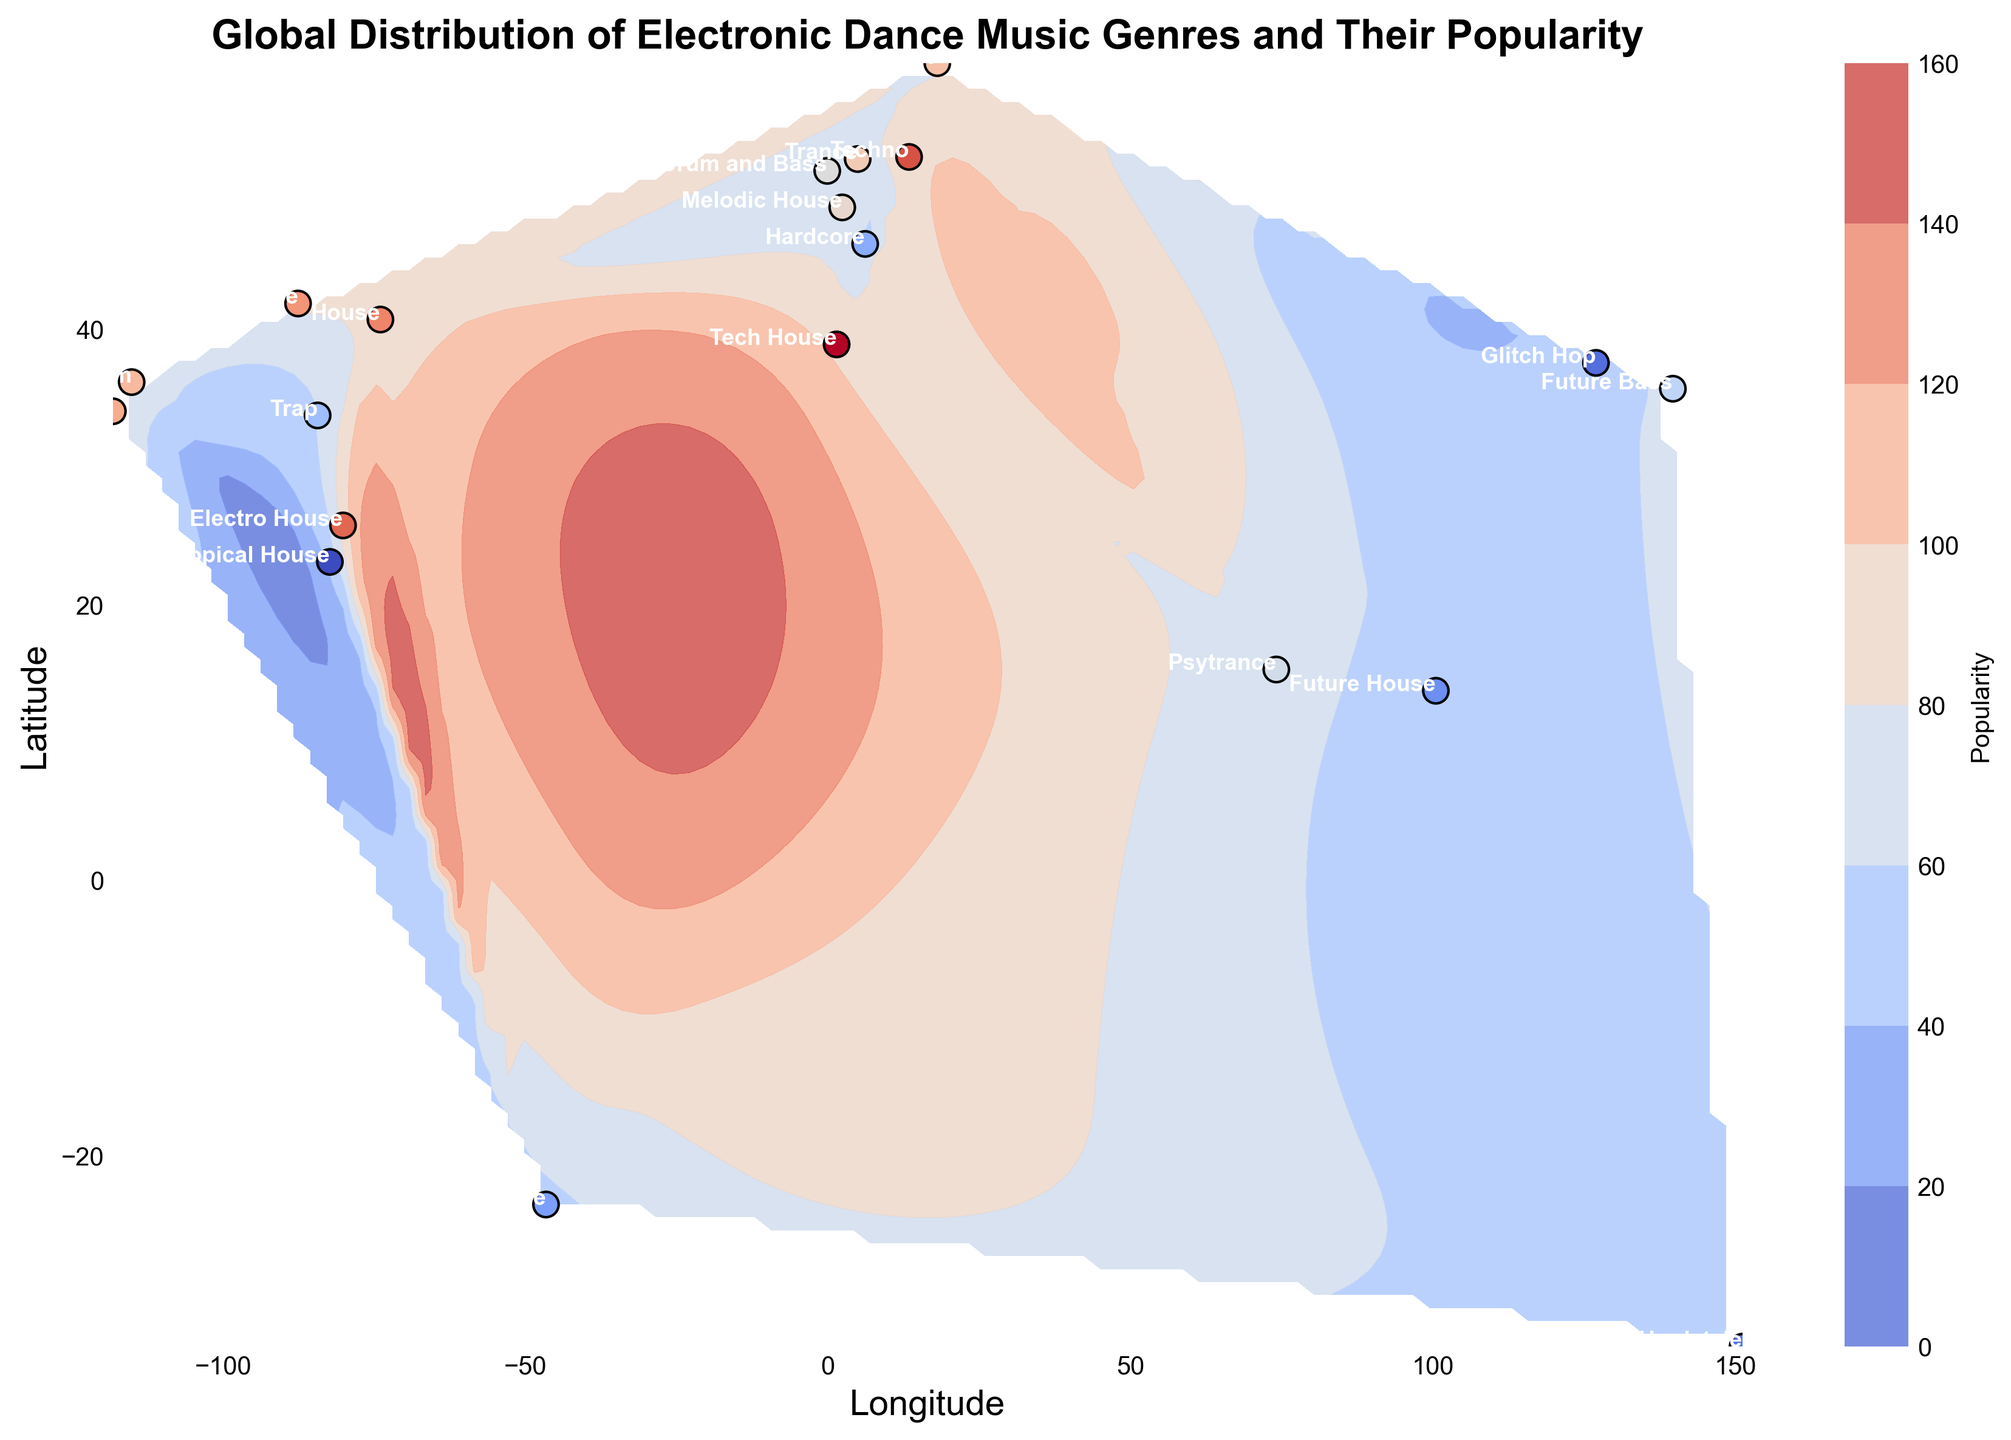How many genres have a popularity greater than 80? From the scatter points on the plot, count the number of genres whose colors are near the highest end of the color bar, indicating a popularity greater than 80. The genres are: House, Techno, Tech House, Electro House, and Deep House.
Answer: 5 Which genre is located the furthest south? Identify the scatter point with the lowest latitude value. The genre at the most southern latitude is Hardstyle in Sydney.
Answer: Hardstyle Which genre appears to be the most popular globally? Look at the color bar indicating popularity and find the darkest/most saturated color on the plot. The genre with this color is Tech House in Ibiza with a popularity around 95.
Answer: Tech House Compare the popularity of genres between Berlin and Amsterdam. Which one is more popular? Locate Berlin and Amsterdam on the plot. Observe their scatter point colors and refer to the color bar. Berlin (Techno) has a higher popularity (around 90) compared to Amsterdam (Trance) which is around 75.
Answer: Berlin What is the approximate average popularity of genres located on longitude > 0 (eastern hemisphere)? Identify the points in the eastern hemisphere (longitude > 0) and calculate their average popularity: Techno (90), Trance (75), Tech House (95), Future Bass (65), Progressive House (77), Psytrance (68), Melodic House (72), Hardcore (57), Future House (53). Calculate the average of these values. (90 + 75 + 95 + 65 + 77 + 68 + 72 + 57 + 53) / 9 = 72.44
Answer: 72.44 What visual attribute indicates the highest popularity in the contour plot? Locate the regions with the darkest/most saturated red color, as colors close to dark red represent higher popularity according to the color bar.
Answer: Darkest red How many genres are located in cities with latitude less than 0? Identify the points in the Southern Hemisphere (latitude < 0). These are Hardstyle in Sydney and Bass House in Sao Paulo.
Answer: 2 Which genre has a popularity closest to 50? Look at the scatter points and refer to the color bar to find the genre whose color is closest to the median value between the minimum and maximum. Glitch Hop and Hardstyle are closest, both near the value 50.
Answer: Hardstyle and Glitch Hop Compare the popularity of House (New York) and Deep House (Chicago). Which one is more popular? Locate New York and Chicago on the plot, and compare their scatter point colors relative to the color bar. House in New York (85) has a slightly higher popularity than Deep House in Chicago (83).
Answer: House Which continent seems to have the most genres of electronic dance music based on the scatter points? Visually count and identify the number of scatter points on each continent shown in the plot. Europe has the highest concentration with 7 genres.
Answer: Europe 